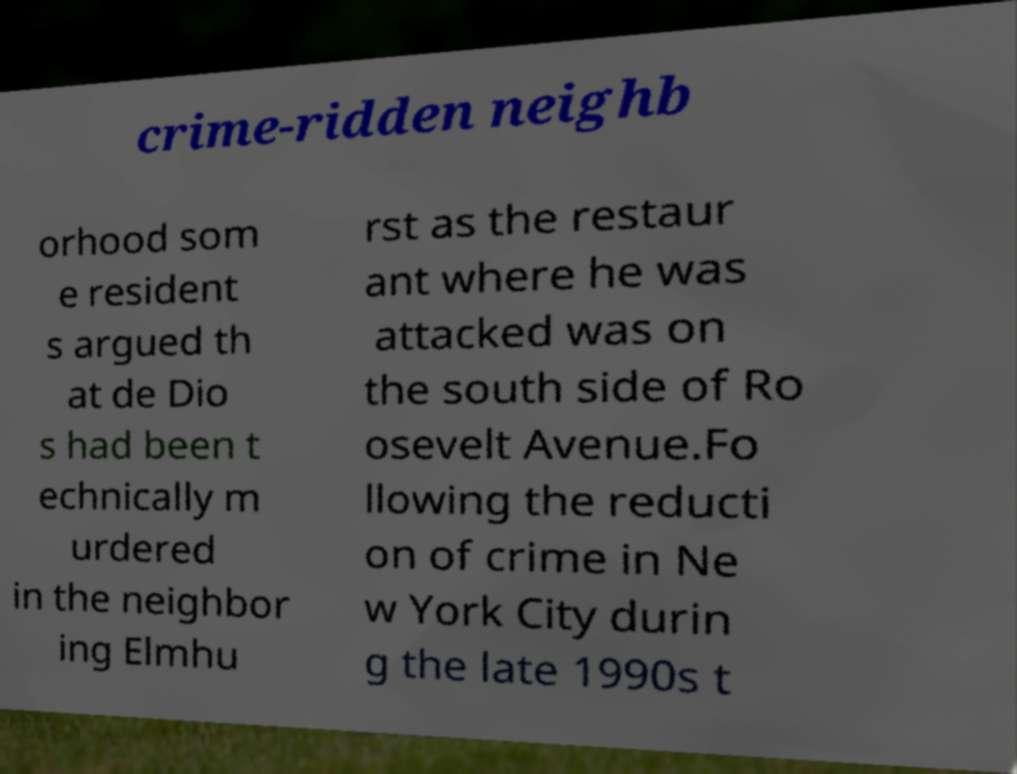There's text embedded in this image that I need extracted. Can you transcribe it verbatim? crime-ridden neighb orhood som e resident s argued th at de Dio s had been t echnically m urdered in the neighbor ing Elmhu rst as the restaur ant where he was attacked was on the south side of Ro osevelt Avenue.Fo llowing the reducti on of crime in Ne w York City durin g the late 1990s t 